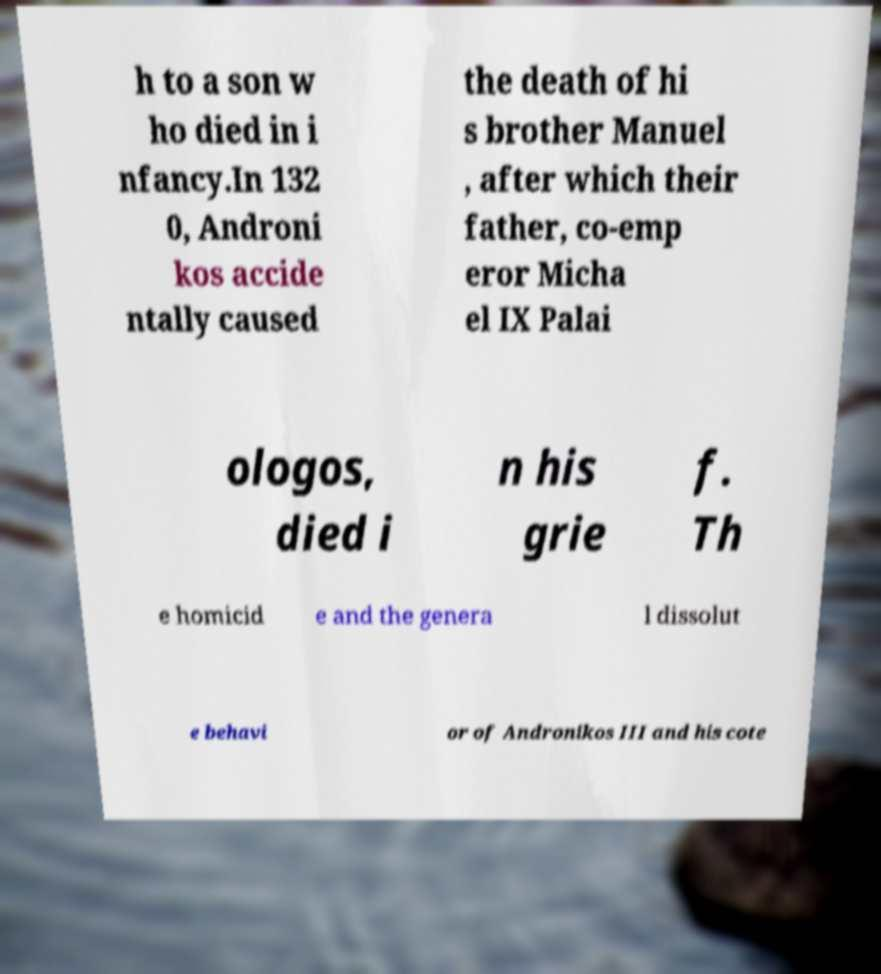There's text embedded in this image that I need extracted. Can you transcribe it verbatim? h to a son w ho died in i nfancy.In 132 0, Androni kos accide ntally caused the death of hi s brother Manuel , after which their father, co-emp eror Micha el IX Palai ologos, died i n his grie f. Th e homicid e and the genera l dissolut e behavi or of Andronikos III and his cote 